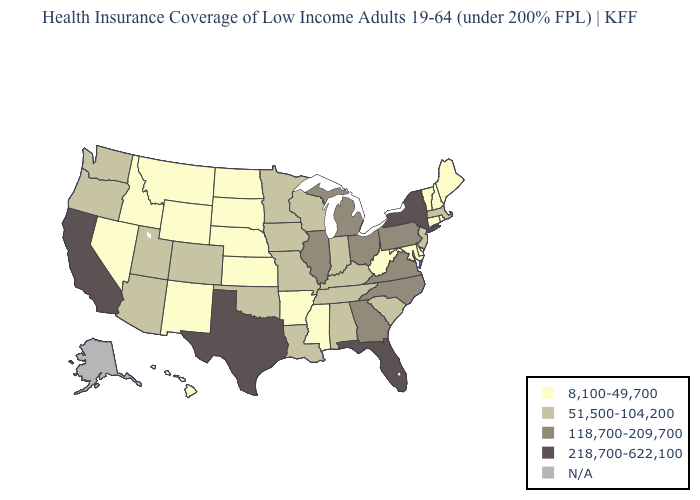Does Arizona have the lowest value in the West?
Quick response, please. No. Name the states that have a value in the range 8,100-49,700?
Give a very brief answer. Arkansas, Connecticut, Delaware, Hawaii, Idaho, Kansas, Maine, Maryland, Mississippi, Montana, Nebraska, Nevada, New Hampshire, New Mexico, North Dakota, Rhode Island, South Dakota, Vermont, West Virginia, Wyoming. Which states have the highest value in the USA?
Concise answer only. California, Florida, New York, Texas. Among the states that border Oregon , does California have the lowest value?
Concise answer only. No. What is the lowest value in the USA?
Answer briefly. 8,100-49,700. What is the highest value in states that border Minnesota?
Be succinct. 51,500-104,200. Name the states that have a value in the range 8,100-49,700?
Write a very short answer. Arkansas, Connecticut, Delaware, Hawaii, Idaho, Kansas, Maine, Maryland, Mississippi, Montana, Nebraska, Nevada, New Hampshire, New Mexico, North Dakota, Rhode Island, South Dakota, Vermont, West Virginia, Wyoming. Is the legend a continuous bar?
Short answer required. No. What is the value of Arkansas?
Give a very brief answer. 8,100-49,700. Does Ohio have the highest value in the MidWest?
Short answer required. Yes. What is the value of Georgia?
Concise answer only. 118,700-209,700. What is the lowest value in states that border Wyoming?
Answer briefly. 8,100-49,700. Name the states that have a value in the range N/A?
Quick response, please. Alaska. Does Kansas have the highest value in the MidWest?
Short answer required. No. Which states have the highest value in the USA?
Answer briefly. California, Florida, New York, Texas. 